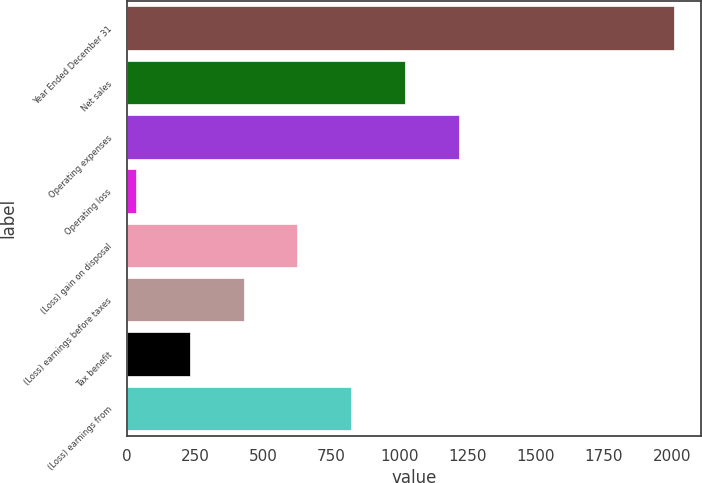<chart> <loc_0><loc_0><loc_500><loc_500><bar_chart><fcel>Year Ended December 31<fcel>Net sales<fcel>Operating expenses<fcel>Operating loss<fcel>(Loss) gain on disposal<fcel>(Loss) earnings before taxes<fcel>Tax benefit<fcel>(Loss) earnings from<nl><fcel>2006<fcel>1020<fcel>1217.2<fcel>34<fcel>625.6<fcel>428.4<fcel>231.2<fcel>822.8<nl></chart> 